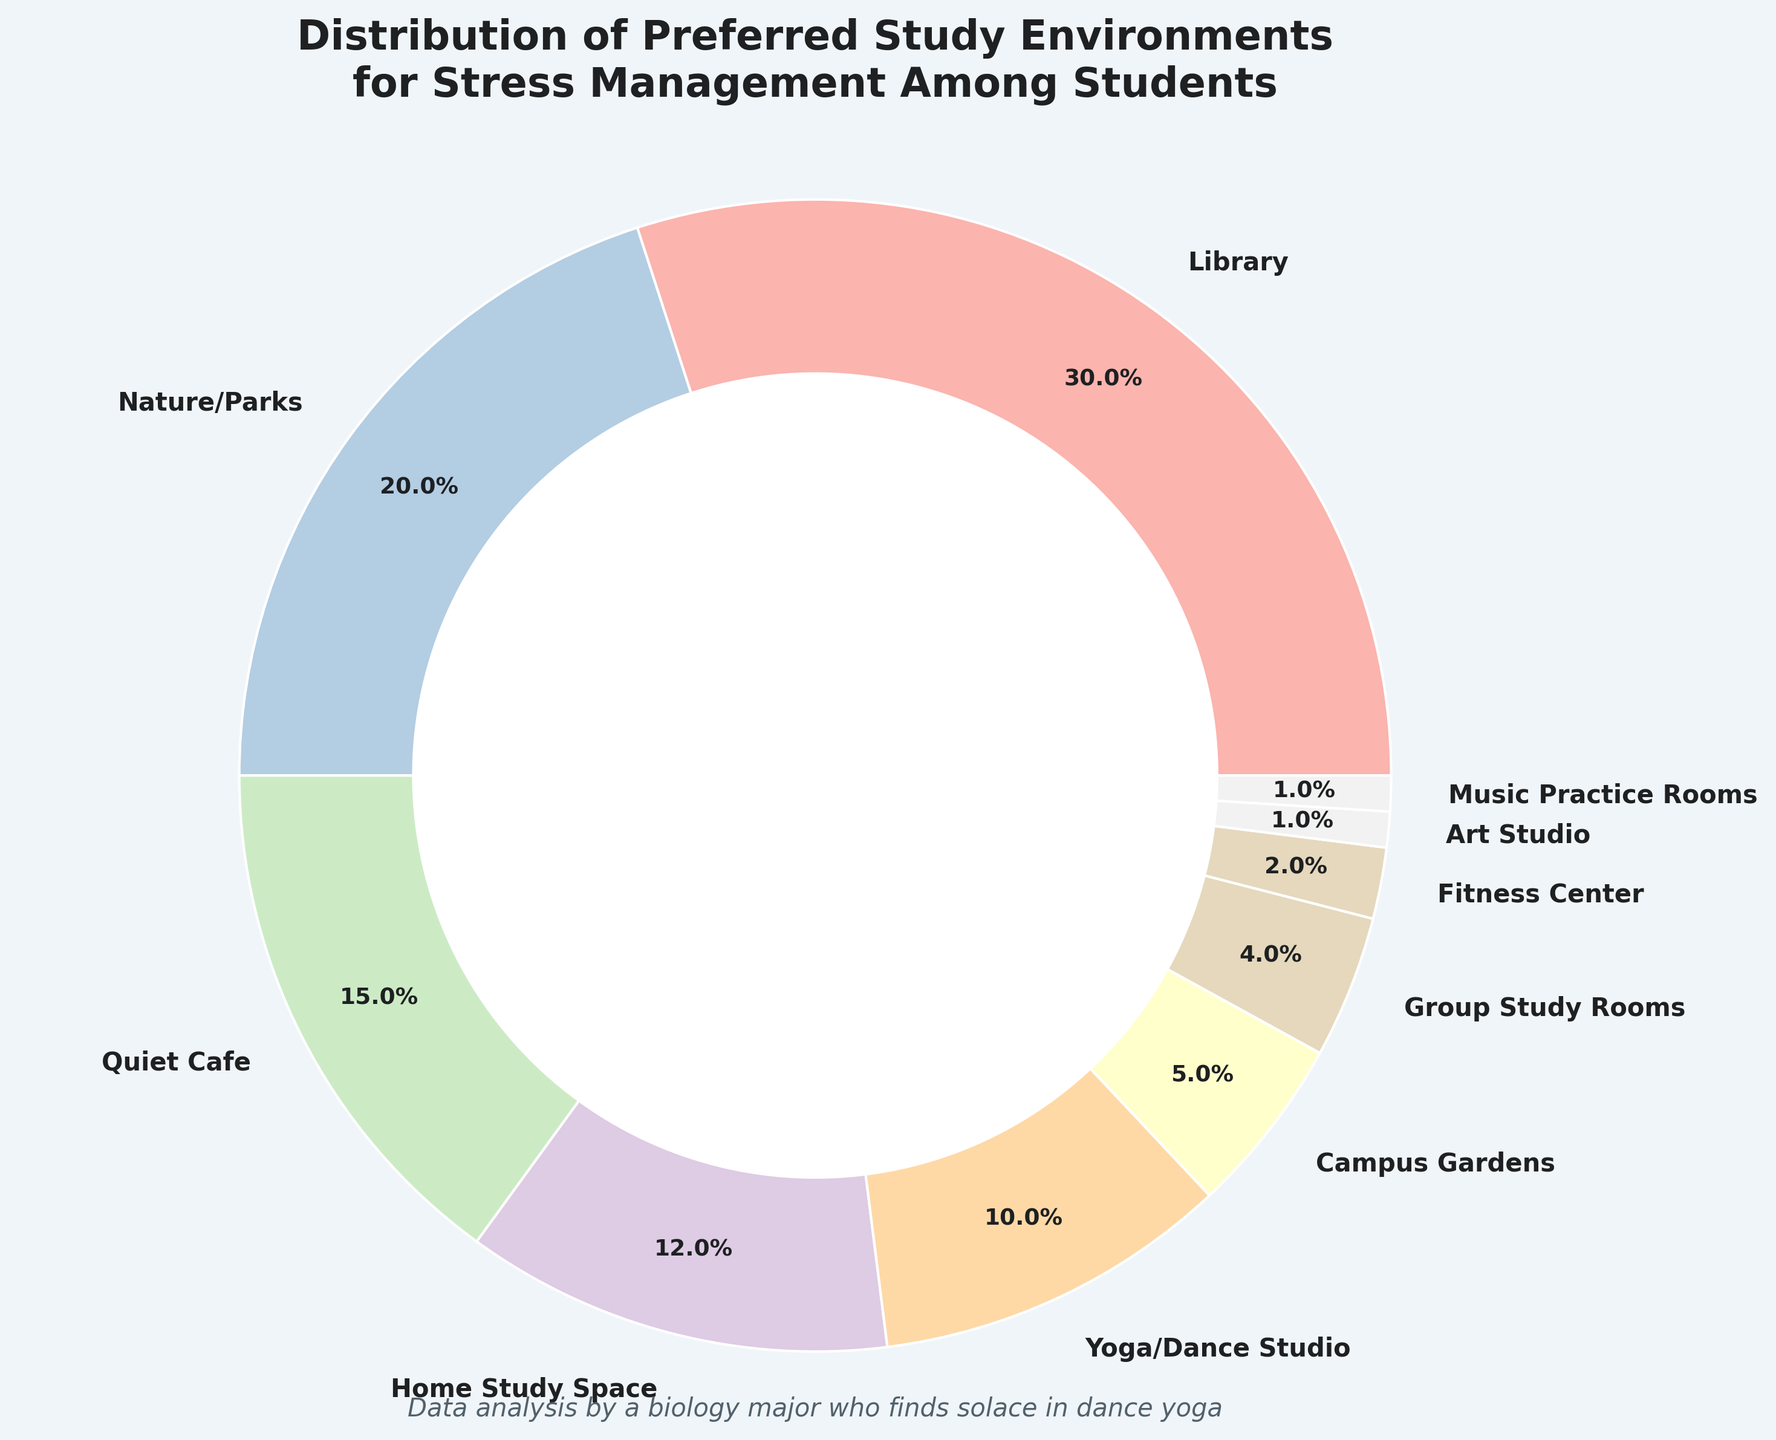What's the most preferred study environment for stress management among students? To determine the most preferred study environment, look for the category with the highest percentage. In the pie chart, the "Library" category has the largest wedge and a percentage label of 30%.
Answer: Library Which study environments are preferred by more than 20% of students? Look for sections in the pie chart with percentage labels greater than 20%. Only "Library" with 30% meets this criterion.
Answer: Library What is the combined percentage of students who prefer either a Library or Nature/Parks for stress management? Identify the percentages for both "Library" and "Nature/Parks" (30% and 20%, respectively). Add them together: 30% + 20% = 50%.
Answer: 50% How does the preference for Quiet Cafe compare to Home Study Space? Compare the percentage labels on the pie chart for "Quiet Cafe" (15%) and "Home Study Space" (12%). The "Quiet Cafe" is preferred by 3% more students than "Home Study Space."
Answer: Quiet Cafe What percentage of students prefer either an Art Studio or Music Practice Rooms? Identify the percentages for both "Art Studio" and "Music Practice Rooms" (1% each). Add them up: 1% + 1% = 2%.
Answer: 2% What is the difference in preference between Fitness Center and Group Study Rooms? Find the percentages for "Fitness Center" (2%) and "Group Study Rooms" (4%). Subtract the smaller percentage from the larger: 4% - 2% = 2%.
Answer: 2% If the sample size is 500 students, how many students prefer studying in the Yoga/Dance Studio? First, find the percentage of students who prefer Yoga/Dance Studio, which is 10%. Then calculate the number of students: 10% of 500 = 0.10 * 500 = 50 students.
Answer: 50 Which study environment has exactly half the preference of the Nature/Parks environment? Find the percentage for "Nature/Parks" (20%). Look for a section with half of this percentage, which is 10%. The "Yoga/Dance Studio" has a 10% preference.
Answer: Yoga/Dance Studio What is the total percentage of students studying in outdoor environments (Nature/Parks and Campus Gardens)? Identify the percentages for "Nature/Parks" (20%) and "Campus Gardens" (5%). Add them together: 20% + 5% = 25%.
Answer: 25% Which study environments are preferred by exactly 1% of students each? Identify sections in the pie chart with a 1% label. "Art Studio" and "Music Practice Rooms" are both preferred by 1% of students each.
Answer: Art Studio, Music Practice Rooms 